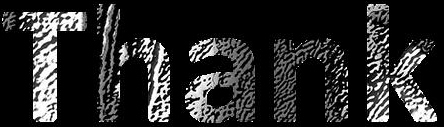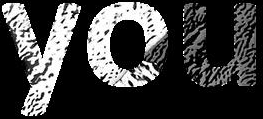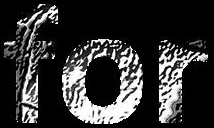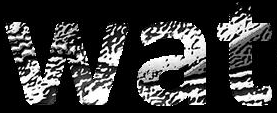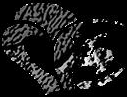Identify the words shown in these images in order, separated by a semicolon. Thank; you; for; wat; # 